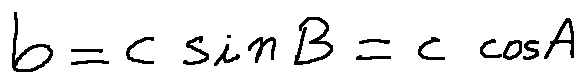<formula> <loc_0><loc_0><loc_500><loc_500>b = c \sin B = c \cos A</formula> 